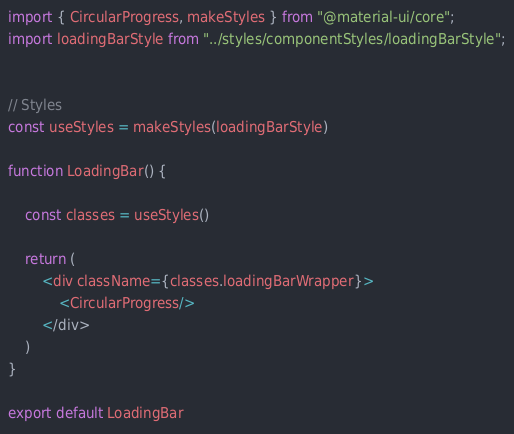<code> <loc_0><loc_0><loc_500><loc_500><_JavaScript_>import { CircularProgress, makeStyles } from "@material-ui/core";
import loadingBarStyle from "../styles/componentStyles/loadingBarStyle";


// Styles
const useStyles = makeStyles(loadingBarStyle)

function LoadingBar() {

    const classes = useStyles()

    return (
        <div className={classes.loadingBarWrapper}>
            <CircularProgress/>
        </div>
    )
}

export default LoadingBar

</code> 